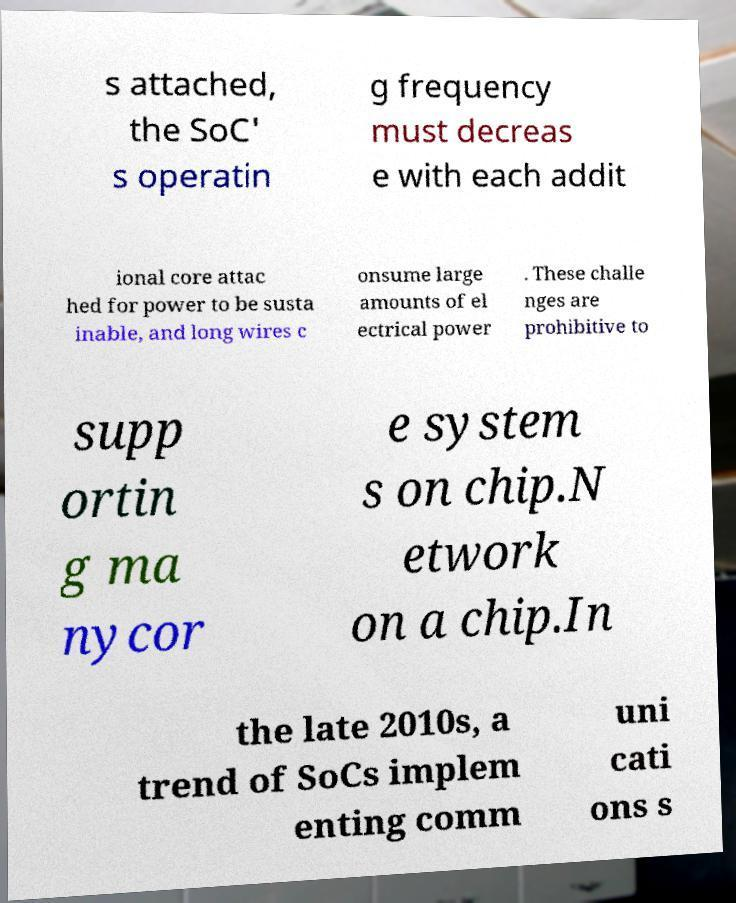I need the written content from this picture converted into text. Can you do that? s attached, the SoC' s operatin g frequency must decreas e with each addit ional core attac hed for power to be susta inable, and long wires c onsume large amounts of el ectrical power . These challe nges are prohibitive to supp ortin g ma nycor e system s on chip.N etwork on a chip.In the late 2010s, a trend of SoCs implem enting comm uni cati ons s 